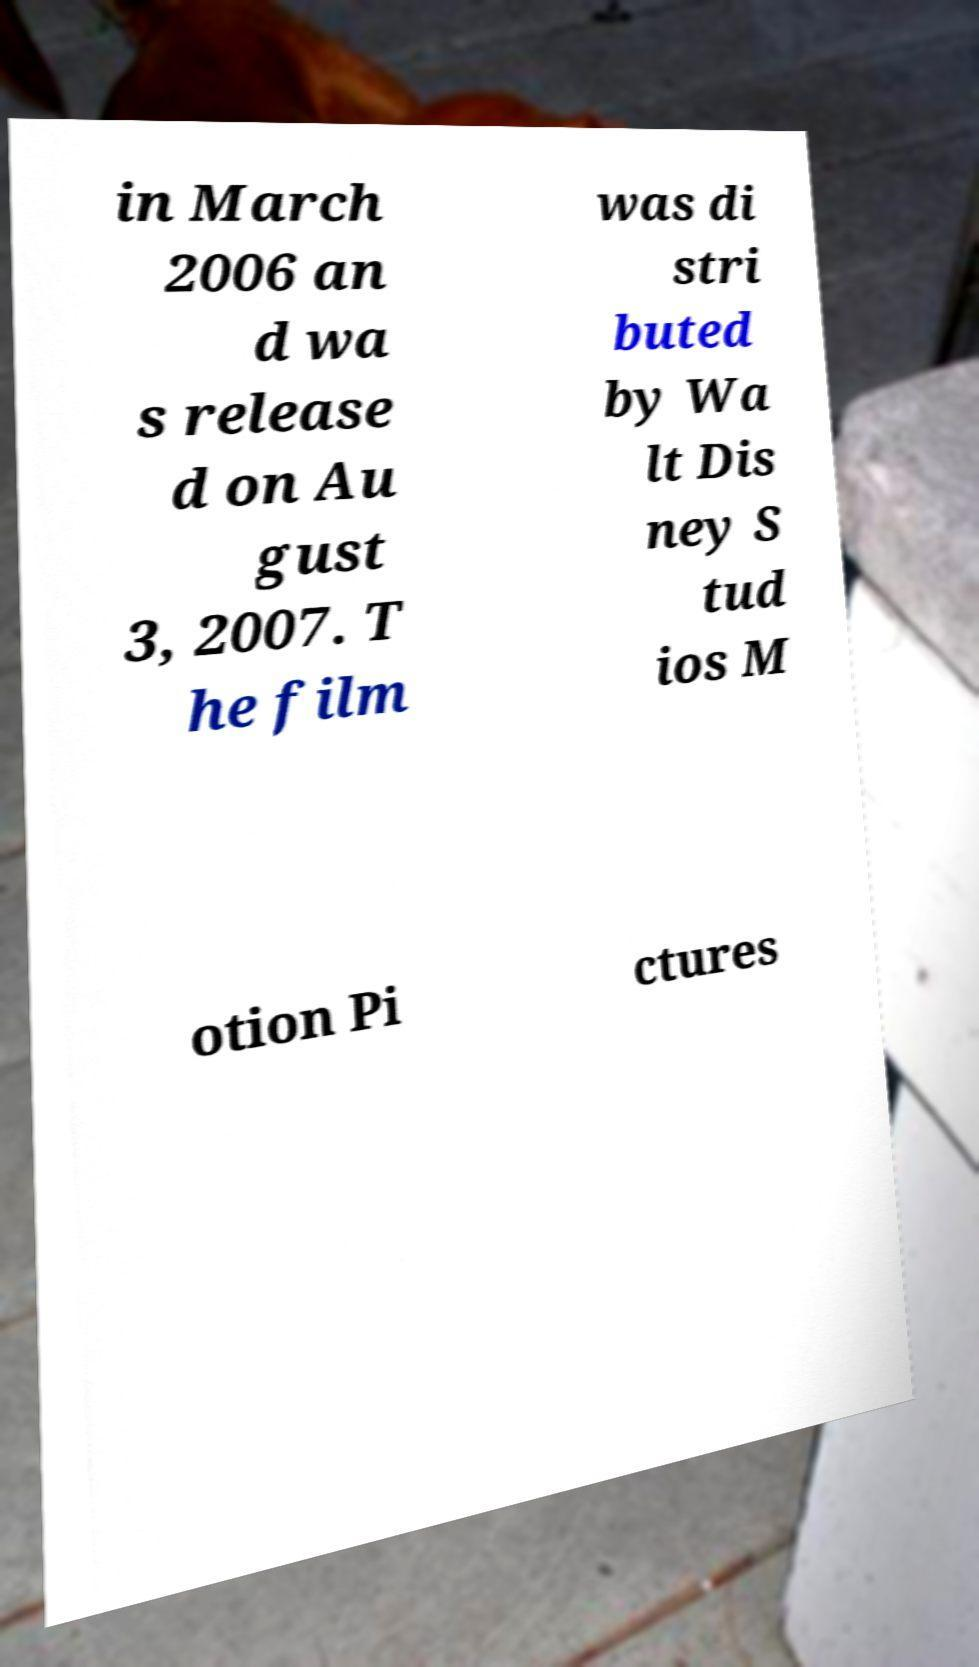There's text embedded in this image that I need extracted. Can you transcribe it verbatim? in March 2006 an d wa s release d on Au gust 3, 2007. T he film was di stri buted by Wa lt Dis ney S tud ios M otion Pi ctures 